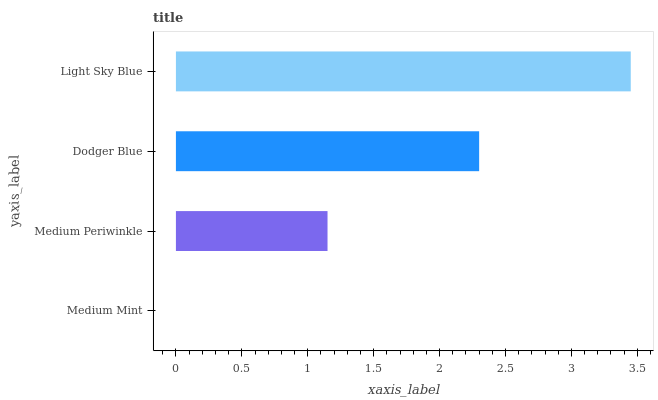Is Medium Mint the minimum?
Answer yes or no. Yes. Is Light Sky Blue the maximum?
Answer yes or no. Yes. Is Medium Periwinkle the minimum?
Answer yes or no. No. Is Medium Periwinkle the maximum?
Answer yes or no. No. Is Medium Periwinkle greater than Medium Mint?
Answer yes or no. Yes. Is Medium Mint less than Medium Periwinkle?
Answer yes or no. Yes. Is Medium Mint greater than Medium Periwinkle?
Answer yes or no. No. Is Medium Periwinkle less than Medium Mint?
Answer yes or no. No. Is Dodger Blue the high median?
Answer yes or no. Yes. Is Medium Periwinkle the low median?
Answer yes or no. Yes. Is Medium Mint the high median?
Answer yes or no. No. Is Dodger Blue the low median?
Answer yes or no. No. 